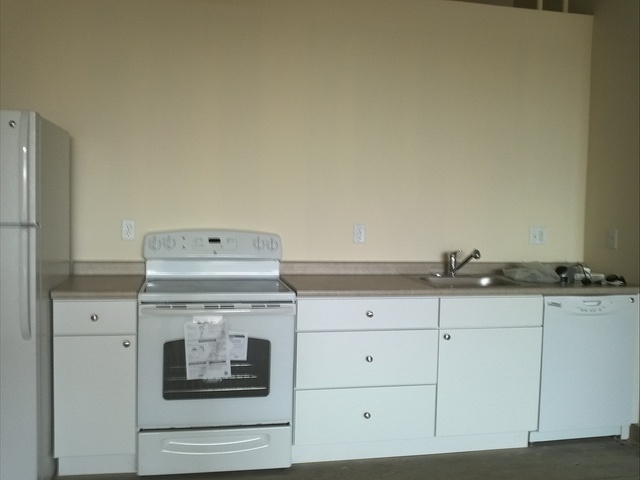Describe the objects in this image and their specific colors. I can see oven in gray, darkgray, lightgray, and black tones, refrigerator in gray and darkgray tones, and sink in gray and black tones in this image. 